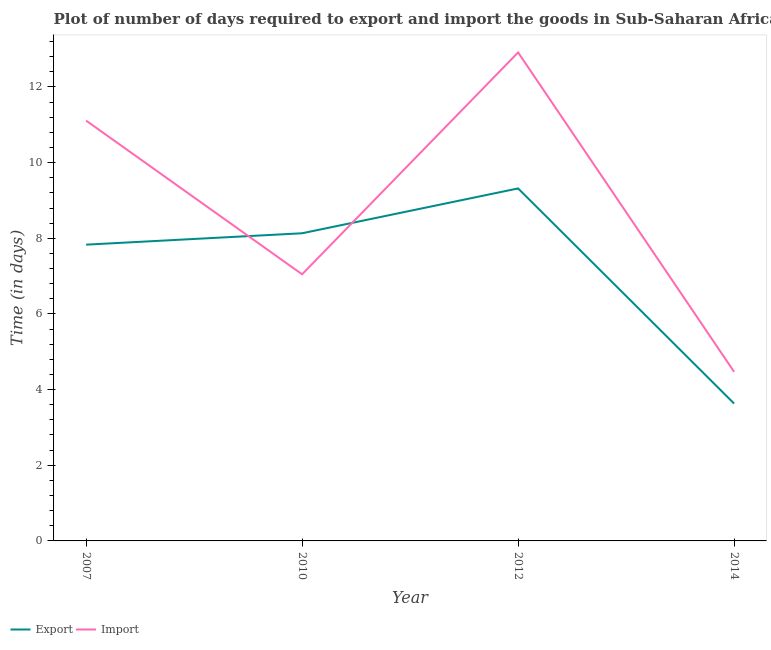Is the number of lines equal to the number of legend labels?
Your answer should be compact. Yes. What is the time required to export in 2010?
Provide a short and direct response. 8.13. Across all years, what is the maximum time required to export?
Your response must be concise. 9.32. Across all years, what is the minimum time required to import?
Offer a very short reply. 4.47. In which year was the time required to export minimum?
Your answer should be very brief. 2014. What is the total time required to import in the graph?
Your response must be concise. 35.54. What is the difference between the time required to import in 2007 and that in 2010?
Ensure brevity in your answer.  4.06. What is the difference between the time required to export in 2012 and the time required to import in 2007?
Ensure brevity in your answer.  -1.79. What is the average time required to import per year?
Your response must be concise. 8.89. In the year 2007, what is the difference between the time required to import and time required to export?
Give a very brief answer. 3.28. What is the ratio of the time required to import in 2007 to that in 2010?
Offer a very short reply. 1.58. Is the time required to export in 2007 less than that in 2014?
Offer a very short reply. No. What is the difference between the highest and the second highest time required to import?
Provide a short and direct response. 1.8. What is the difference between the highest and the lowest time required to import?
Offer a very short reply. 8.44. Is the sum of the time required to import in 2007 and 2012 greater than the maximum time required to export across all years?
Give a very brief answer. Yes. Does the time required to export monotonically increase over the years?
Make the answer very short. No. Is the time required to export strictly greater than the time required to import over the years?
Provide a short and direct response. No. How many years are there in the graph?
Offer a very short reply. 4. What is the difference between two consecutive major ticks on the Y-axis?
Your answer should be compact. 2. Are the values on the major ticks of Y-axis written in scientific E-notation?
Offer a very short reply. No. How many legend labels are there?
Give a very brief answer. 2. What is the title of the graph?
Provide a short and direct response. Plot of number of days required to export and import the goods in Sub-Saharan Africa (all income levels). What is the label or title of the Y-axis?
Give a very brief answer. Time (in days). What is the Time (in days) in Export in 2007?
Provide a short and direct response. 7.83. What is the Time (in days) in Import in 2007?
Your response must be concise. 11.11. What is the Time (in days) in Export in 2010?
Your answer should be very brief. 8.13. What is the Time (in days) in Import in 2010?
Your answer should be very brief. 7.05. What is the Time (in days) of Export in 2012?
Provide a short and direct response. 9.32. What is the Time (in days) of Import in 2012?
Offer a very short reply. 12.91. What is the Time (in days) in Export in 2014?
Your response must be concise. 3.63. What is the Time (in days) of Import in 2014?
Ensure brevity in your answer.  4.47. Across all years, what is the maximum Time (in days) of Export?
Provide a short and direct response. 9.32. Across all years, what is the maximum Time (in days) in Import?
Your response must be concise. 12.91. Across all years, what is the minimum Time (in days) in Export?
Provide a short and direct response. 3.63. Across all years, what is the minimum Time (in days) in Import?
Your answer should be compact. 4.47. What is the total Time (in days) in Export in the graph?
Your answer should be compact. 28.91. What is the total Time (in days) in Import in the graph?
Offer a very short reply. 35.54. What is the difference between the Time (in days) of Export in 2007 and that in 2010?
Your response must be concise. -0.3. What is the difference between the Time (in days) of Import in 2007 and that in 2010?
Offer a terse response. 4.06. What is the difference between the Time (in days) in Export in 2007 and that in 2012?
Offer a terse response. -1.49. What is the difference between the Time (in days) of Import in 2007 and that in 2012?
Offer a very short reply. -1.8. What is the difference between the Time (in days) in Import in 2007 and that in 2014?
Your response must be concise. 6.64. What is the difference between the Time (in days) of Export in 2010 and that in 2012?
Your answer should be very brief. -1.19. What is the difference between the Time (in days) of Import in 2010 and that in 2012?
Your answer should be compact. -5.86. What is the difference between the Time (in days) in Export in 2010 and that in 2014?
Ensure brevity in your answer.  4.5. What is the difference between the Time (in days) of Import in 2010 and that in 2014?
Your response must be concise. 2.58. What is the difference between the Time (in days) in Export in 2012 and that in 2014?
Keep it short and to the point. 5.69. What is the difference between the Time (in days) of Import in 2012 and that in 2014?
Your response must be concise. 8.44. What is the difference between the Time (in days) of Export in 2007 and the Time (in days) of Import in 2010?
Provide a succinct answer. 0.78. What is the difference between the Time (in days) in Export in 2007 and the Time (in days) in Import in 2012?
Offer a very short reply. -5.08. What is the difference between the Time (in days) in Export in 2007 and the Time (in days) in Import in 2014?
Provide a short and direct response. 3.36. What is the difference between the Time (in days) in Export in 2010 and the Time (in days) in Import in 2012?
Give a very brief answer. -4.78. What is the difference between the Time (in days) of Export in 2010 and the Time (in days) of Import in 2014?
Make the answer very short. 3.66. What is the difference between the Time (in days) of Export in 2012 and the Time (in days) of Import in 2014?
Offer a terse response. 4.85. What is the average Time (in days) in Export per year?
Keep it short and to the point. 7.23. What is the average Time (in days) of Import per year?
Keep it short and to the point. 8.89. In the year 2007, what is the difference between the Time (in days) in Export and Time (in days) in Import?
Offer a terse response. -3.28. In the year 2010, what is the difference between the Time (in days) in Export and Time (in days) in Import?
Give a very brief answer. 1.08. In the year 2012, what is the difference between the Time (in days) of Export and Time (in days) of Import?
Make the answer very short. -3.59. In the year 2014, what is the difference between the Time (in days) in Export and Time (in days) in Import?
Make the answer very short. -0.84. What is the ratio of the Time (in days) of Export in 2007 to that in 2010?
Ensure brevity in your answer.  0.96. What is the ratio of the Time (in days) of Import in 2007 to that in 2010?
Your answer should be very brief. 1.58. What is the ratio of the Time (in days) in Export in 2007 to that in 2012?
Make the answer very short. 0.84. What is the ratio of the Time (in days) of Import in 2007 to that in 2012?
Provide a short and direct response. 0.86. What is the ratio of the Time (in days) of Export in 2007 to that in 2014?
Provide a succinct answer. 2.16. What is the ratio of the Time (in days) in Import in 2007 to that in 2014?
Provide a short and direct response. 2.49. What is the ratio of the Time (in days) of Export in 2010 to that in 2012?
Your response must be concise. 0.87. What is the ratio of the Time (in days) of Import in 2010 to that in 2012?
Keep it short and to the point. 0.55. What is the ratio of the Time (in days) of Export in 2010 to that in 2014?
Keep it short and to the point. 2.24. What is the ratio of the Time (in days) of Import in 2010 to that in 2014?
Make the answer very short. 1.58. What is the ratio of the Time (in days) in Export in 2012 to that in 2014?
Your answer should be very brief. 2.57. What is the ratio of the Time (in days) in Import in 2012 to that in 2014?
Give a very brief answer. 2.89. What is the difference between the highest and the second highest Time (in days) in Export?
Your response must be concise. 1.19. What is the difference between the highest and the second highest Time (in days) of Import?
Offer a very short reply. 1.8. What is the difference between the highest and the lowest Time (in days) of Export?
Your response must be concise. 5.69. What is the difference between the highest and the lowest Time (in days) in Import?
Ensure brevity in your answer.  8.44. 